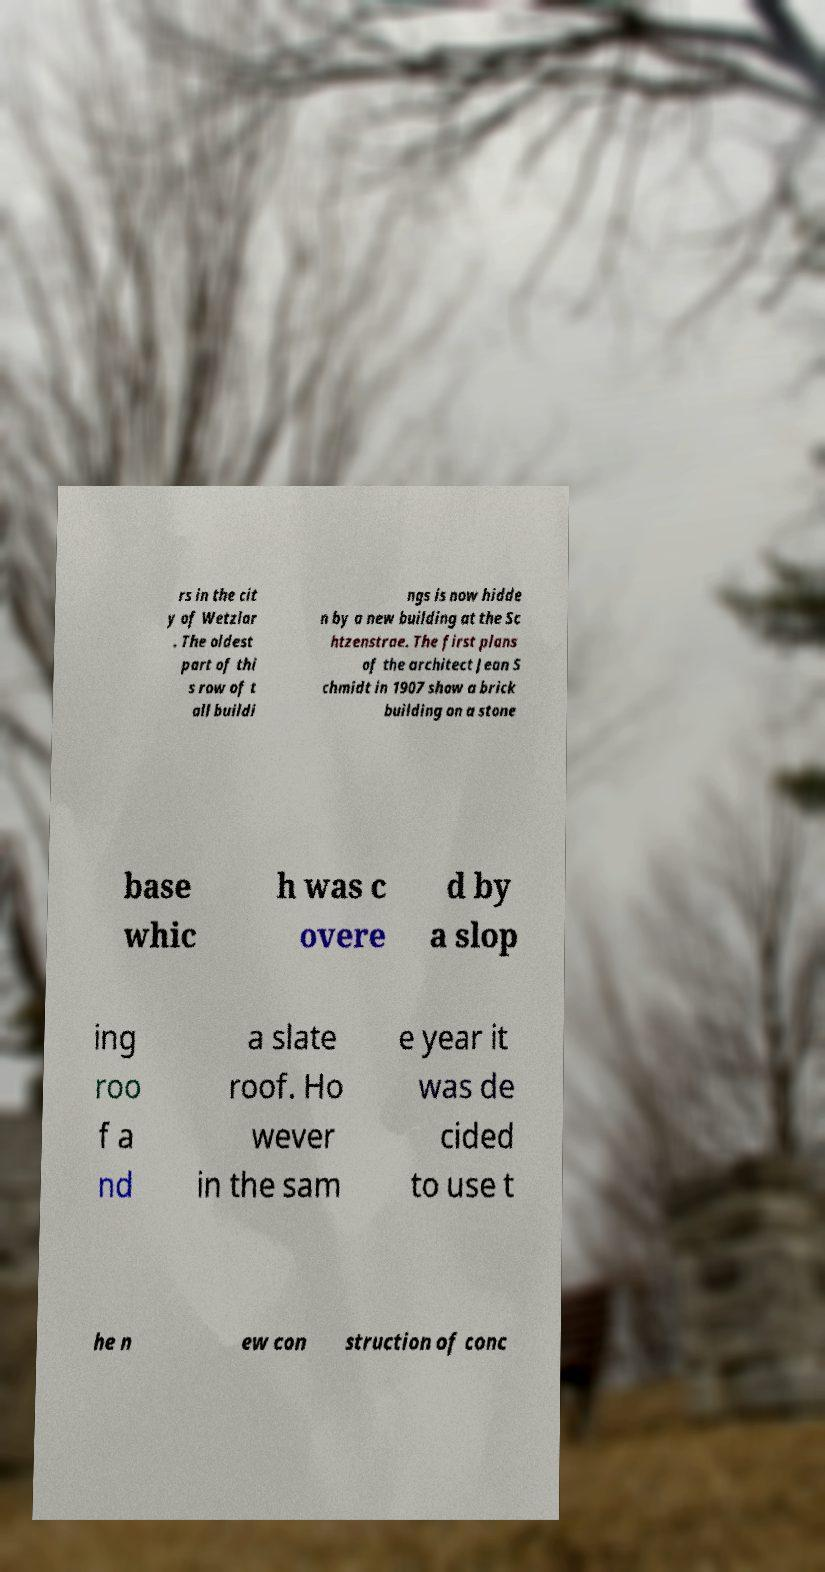For documentation purposes, I need the text within this image transcribed. Could you provide that? rs in the cit y of Wetzlar . The oldest part of thi s row of t all buildi ngs is now hidde n by a new building at the Sc htzenstrae. The first plans of the architect Jean S chmidt in 1907 show a brick building on a stone base whic h was c overe d by a slop ing roo f a nd a slate roof. Ho wever in the sam e year it was de cided to use t he n ew con struction of conc 